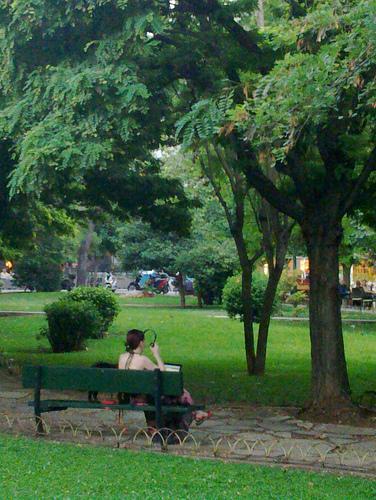How many benches are shown?
Give a very brief answer. 1. How many bushes are to the left of the woman on the park bench?
Give a very brief answer. 2. 